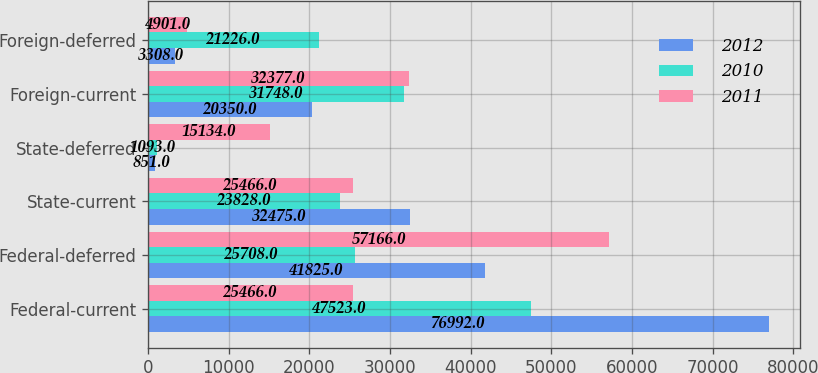Convert chart. <chart><loc_0><loc_0><loc_500><loc_500><stacked_bar_chart><ecel><fcel>Federal-current<fcel>Federal-deferred<fcel>State-current<fcel>State-deferred<fcel>Foreign-current<fcel>Foreign-deferred<nl><fcel>2012<fcel>76992<fcel>41825<fcel>32475<fcel>851<fcel>20350<fcel>3308<nl><fcel>2010<fcel>47523<fcel>25708<fcel>23828<fcel>1093<fcel>31748<fcel>21226<nl><fcel>2011<fcel>25466<fcel>57166<fcel>25466<fcel>15134<fcel>32377<fcel>4901<nl></chart> 